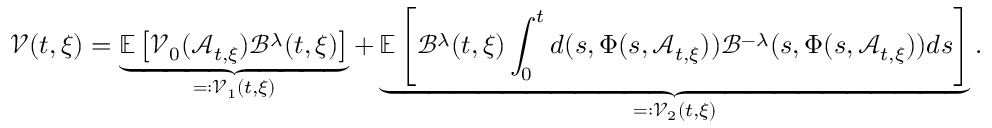Convert formula to latex. <formula><loc_0><loc_0><loc_500><loc_500>\mathcal { V } ( t , \xi ) = \underbrace { \mathbb { E } \left [ \mathcal { V } _ { 0 } ( \mathcal { A } _ { t , \xi } ) \mathcal { B } ^ { \lambda } ( t , \xi ) \right ] } _ { = \colon \mathcal { V } _ { 1 } ( t , \xi ) } + \underbrace { \mathbb { E } \left [ \mathcal { B } ^ { \lambda } ( t , \xi ) \int _ { 0 } ^ { t } d ( s , \Phi ( s , \mathcal { A } _ { t , \xi } ) ) \mathcal { B } ^ { - \lambda } ( s , \Phi ( s , \mathcal { A } _ { t , \xi } ) ) d s \right ] } _ { = \colon \mathcal { V } _ { 2 } ( t , \xi ) } .</formula> 